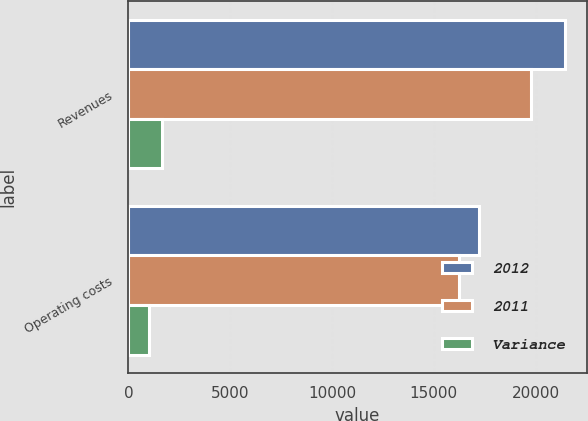Convert chart to OTSL. <chart><loc_0><loc_0><loc_500><loc_500><stacked_bar_chart><ecel><fcel>Revenues<fcel>Operating costs<nl><fcel>2012<fcel>21440<fcel>17230<nl><fcel>2011<fcel>19784<fcel>16228<nl><fcel>Variance<fcel>1656<fcel>1002<nl></chart> 